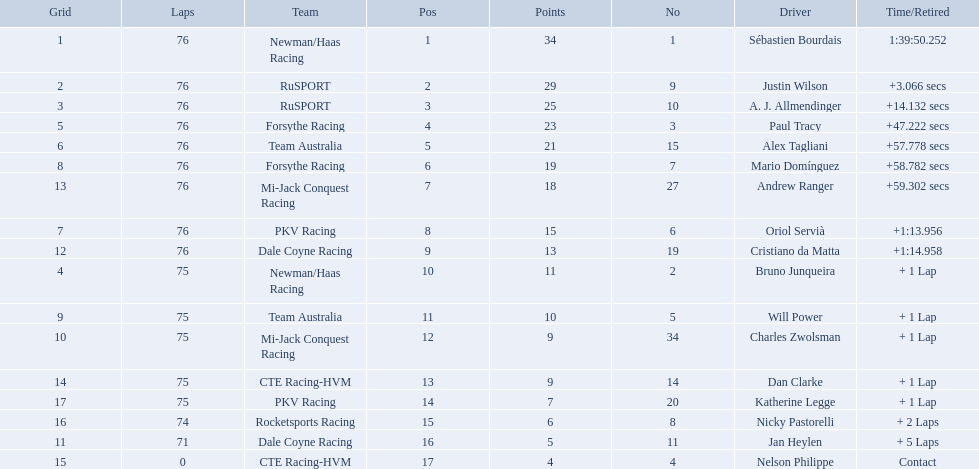Help me parse the entirety of this table. {'header': ['Grid', 'Laps', 'Team', 'Pos', 'Points', 'No', 'Driver', 'Time/Retired'], 'rows': [['1', '76', 'Newman/Haas Racing', '1', '34', '1', 'Sébastien Bourdais', '1:39:50.252'], ['2', '76', 'RuSPORT', '2', '29', '9', 'Justin Wilson', '+3.066 secs'], ['3', '76', 'RuSPORT', '3', '25', '10', 'A. J. Allmendinger', '+14.132 secs'], ['5', '76', 'Forsythe Racing', '4', '23', '3', 'Paul Tracy', '+47.222 secs'], ['6', '76', 'Team Australia', '5', '21', '15', 'Alex Tagliani', '+57.778 secs'], ['8', '76', 'Forsythe Racing', '6', '19', '7', 'Mario Domínguez', '+58.782 secs'], ['13', '76', 'Mi-Jack Conquest Racing', '7', '18', '27', 'Andrew Ranger', '+59.302 secs'], ['7', '76', 'PKV Racing', '8', '15', '6', 'Oriol Servià', '+1:13.956'], ['12', '76', 'Dale Coyne Racing', '9', '13', '19', 'Cristiano da Matta', '+1:14.958'], ['4', '75', 'Newman/Haas Racing', '10', '11', '2', 'Bruno Junqueira', '+ 1 Lap'], ['9', '75', 'Team Australia', '11', '10', '5', 'Will Power', '+ 1 Lap'], ['10', '75', 'Mi-Jack Conquest Racing', '12', '9', '34', 'Charles Zwolsman', '+ 1 Lap'], ['14', '75', 'CTE Racing-HVM', '13', '9', '14', 'Dan Clarke', '+ 1 Lap'], ['17', '75', 'PKV Racing', '14', '7', '20', 'Katherine Legge', '+ 1 Lap'], ['16', '74', 'Rocketsports Racing', '15', '6', '8', 'Nicky Pastorelli', '+ 2 Laps'], ['11', '71', 'Dale Coyne Racing', '16', '5', '11', 'Jan Heylen', '+ 5 Laps'], ['15', '0', 'CTE Racing-HVM', '17', '4', '4', 'Nelson Philippe', 'Contact']]} Is there a driver named charles zwolsman? Charles Zwolsman. How many points did he acquire? 9. Were there any other entries that got the same number of points? 9. Who did that entry belong to? Dan Clarke. 